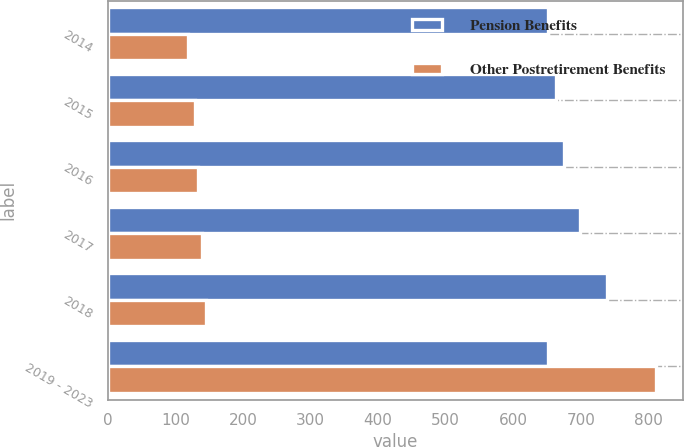Convert chart. <chart><loc_0><loc_0><loc_500><loc_500><stacked_bar_chart><ecel><fcel>2014<fcel>2015<fcel>2016<fcel>2017<fcel>2018<fcel>2019 - 2023<nl><fcel>Pension Benefits<fcel>651<fcel>663<fcel>675<fcel>699<fcel>739<fcel>651<nl><fcel>Other Postretirement Benefits<fcel>119<fcel>129<fcel>134<fcel>139<fcel>145<fcel>811<nl></chart> 